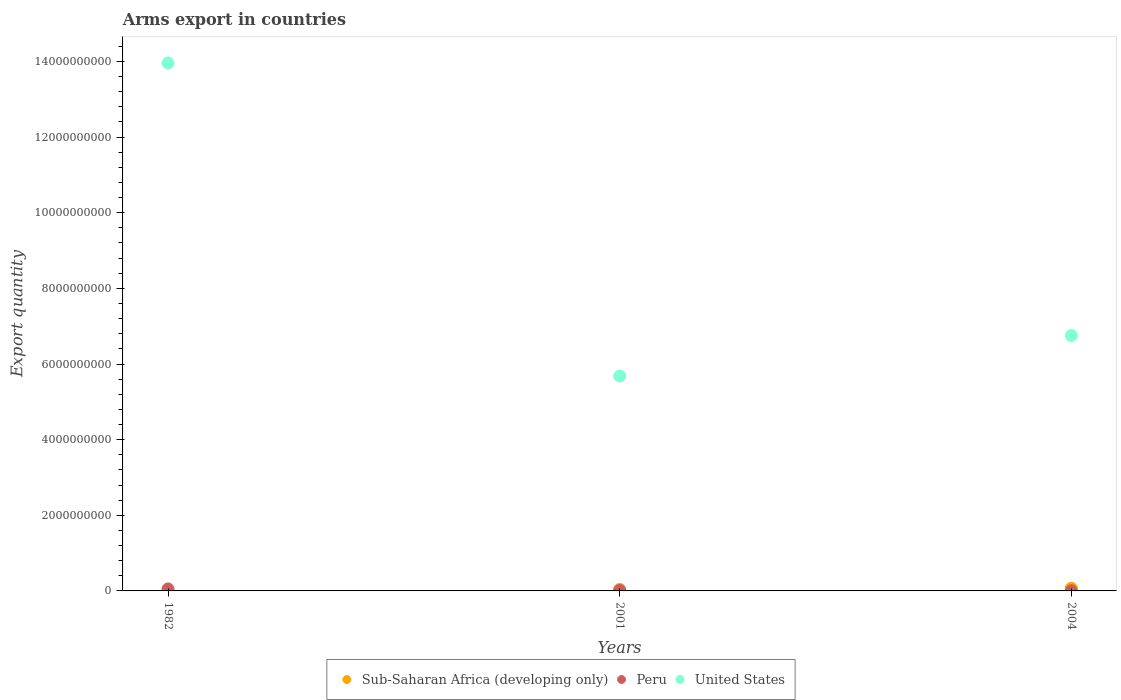How many different coloured dotlines are there?
Offer a terse response. 3. What is the total arms export in United States in 2004?
Provide a short and direct response. 6.75e+09. Across all years, what is the maximum total arms export in Peru?
Offer a terse response. 5.30e+07. Across all years, what is the minimum total arms export in United States?
Keep it short and to the point. 5.68e+09. In which year was the total arms export in United States minimum?
Ensure brevity in your answer.  2001. What is the total total arms export in Sub-Saharan Africa (developing only) in the graph?
Make the answer very short. 1.14e+08. What is the difference between the total arms export in Peru in 1982 and that in 2004?
Your answer should be very brief. 4.80e+07. What is the difference between the total arms export in United States in 2004 and the total arms export in Sub-Saharan Africa (developing only) in 1982?
Your response must be concise. 6.75e+09. What is the average total arms export in Sub-Saharan Africa (developing only) per year?
Provide a short and direct response. 3.80e+07. In the year 1982, what is the difference between the total arms export in United States and total arms export in Sub-Saharan Africa (developing only)?
Offer a very short reply. 1.40e+1. In how many years, is the total arms export in Sub-Saharan Africa (developing only) greater than 4000000000?
Your answer should be very brief. 0. What is the ratio of the total arms export in United States in 1982 to that in 2001?
Your response must be concise. 2.46. Is the total arms export in Sub-Saharan Africa (developing only) in 1982 less than that in 2004?
Give a very brief answer. Yes. What is the difference between the highest and the second highest total arms export in Peru?
Make the answer very short. 3.90e+07. What is the difference between the highest and the lowest total arms export in United States?
Ensure brevity in your answer.  8.28e+09. Is the sum of the total arms export in Sub-Saharan Africa (developing only) in 1982 and 2004 greater than the maximum total arms export in United States across all years?
Provide a succinct answer. No. How many dotlines are there?
Make the answer very short. 3. How many years are there in the graph?
Your response must be concise. 3. What is the difference between two consecutive major ticks on the Y-axis?
Ensure brevity in your answer.  2.00e+09. Are the values on the major ticks of Y-axis written in scientific E-notation?
Your answer should be compact. No. How are the legend labels stacked?
Provide a short and direct response. Horizontal. What is the title of the graph?
Ensure brevity in your answer.  Arms export in countries. What is the label or title of the X-axis?
Keep it short and to the point. Years. What is the label or title of the Y-axis?
Your response must be concise. Export quantity. What is the Export quantity of Peru in 1982?
Your answer should be very brief. 5.30e+07. What is the Export quantity in United States in 1982?
Your answer should be compact. 1.40e+1. What is the Export quantity in Sub-Saharan Africa (developing only) in 2001?
Offer a terse response. 4.10e+07. What is the Export quantity of Peru in 2001?
Provide a succinct answer. 1.40e+07. What is the Export quantity in United States in 2001?
Make the answer very short. 5.68e+09. What is the Export quantity of Sub-Saharan Africa (developing only) in 2004?
Your answer should be compact. 7.20e+07. What is the Export quantity of United States in 2004?
Your response must be concise. 6.75e+09. Across all years, what is the maximum Export quantity in Sub-Saharan Africa (developing only)?
Your answer should be very brief. 7.20e+07. Across all years, what is the maximum Export quantity in Peru?
Provide a short and direct response. 5.30e+07. Across all years, what is the maximum Export quantity of United States?
Your response must be concise. 1.40e+1. Across all years, what is the minimum Export quantity of United States?
Provide a short and direct response. 5.68e+09. What is the total Export quantity of Sub-Saharan Africa (developing only) in the graph?
Offer a terse response. 1.14e+08. What is the total Export quantity in Peru in the graph?
Your answer should be very brief. 7.20e+07. What is the total Export quantity in United States in the graph?
Offer a terse response. 2.64e+1. What is the difference between the Export quantity in Sub-Saharan Africa (developing only) in 1982 and that in 2001?
Ensure brevity in your answer.  -4.00e+07. What is the difference between the Export quantity in Peru in 1982 and that in 2001?
Offer a very short reply. 3.90e+07. What is the difference between the Export quantity of United States in 1982 and that in 2001?
Keep it short and to the point. 8.28e+09. What is the difference between the Export quantity of Sub-Saharan Africa (developing only) in 1982 and that in 2004?
Your answer should be very brief. -7.10e+07. What is the difference between the Export quantity of Peru in 1982 and that in 2004?
Give a very brief answer. 4.80e+07. What is the difference between the Export quantity of United States in 1982 and that in 2004?
Keep it short and to the point. 7.21e+09. What is the difference between the Export quantity of Sub-Saharan Africa (developing only) in 2001 and that in 2004?
Your answer should be compact. -3.10e+07. What is the difference between the Export quantity of Peru in 2001 and that in 2004?
Provide a short and direct response. 9.00e+06. What is the difference between the Export quantity of United States in 2001 and that in 2004?
Offer a terse response. -1.07e+09. What is the difference between the Export quantity of Sub-Saharan Africa (developing only) in 1982 and the Export quantity of Peru in 2001?
Your answer should be very brief. -1.30e+07. What is the difference between the Export quantity in Sub-Saharan Africa (developing only) in 1982 and the Export quantity in United States in 2001?
Your answer should be very brief. -5.68e+09. What is the difference between the Export quantity in Peru in 1982 and the Export quantity in United States in 2001?
Your response must be concise. -5.63e+09. What is the difference between the Export quantity of Sub-Saharan Africa (developing only) in 1982 and the Export quantity of Peru in 2004?
Offer a very short reply. -4.00e+06. What is the difference between the Export quantity in Sub-Saharan Africa (developing only) in 1982 and the Export quantity in United States in 2004?
Ensure brevity in your answer.  -6.75e+09. What is the difference between the Export quantity of Peru in 1982 and the Export quantity of United States in 2004?
Offer a very short reply. -6.70e+09. What is the difference between the Export quantity of Sub-Saharan Africa (developing only) in 2001 and the Export quantity of Peru in 2004?
Your answer should be compact. 3.60e+07. What is the difference between the Export quantity of Sub-Saharan Africa (developing only) in 2001 and the Export quantity of United States in 2004?
Give a very brief answer. -6.71e+09. What is the difference between the Export quantity in Peru in 2001 and the Export quantity in United States in 2004?
Provide a succinct answer. -6.74e+09. What is the average Export quantity of Sub-Saharan Africa (developing only) per year?
Provide a succinct answer. 3.80e+07. What is the average Export quantity in Peru per year?
Provide a short and direct response. 2.40e+07. What is the average Export quantity in United States per year?
Your response must be concise. 8.80e+09. In the year 1982, what is the difference between the Export quantity in Sub-Saharan Africa (developing only) and Export quantity in Peru?
Offer a very short reply. -5.20e+07. In the year 1982, what is the difference between the Export quantity of Sub-Saharan Africa (developing only) and Export quantity of United States?
Offer a very short reply. -1.40e+1. In the year 1982, what is the difference between the Export quantity in Peru and Export quantity in United States?
Offer a terse response. -1.39e+1. In the year 2001, what is the difference between the Export quantity in Sub-Saharan Africa (developing only) and Export quantity in Peru?
Keep it short and to the point. 2.70e+07. In the year 2001, what is the difference between the Export quantity in Sub-Saharan Africa (developing only) and Export quantity in United States?
Give a very brief answer. -5.64e+09. In the year 2001, what is the difference between the Export quantity in Peru and Export quantity in United States?
Keep it short and to the point. -5.67e+09. In the year 2004, what is the difference between the Export quantity of Sub-Saharan Africa (developing only) and Export quantity of Peru?
Provide a succinct answer. 6.70e+07. In the year 2004, what is the difference between the Export quantity of Sub-Saharan Africa (developing only) and Export quantity of United States?
Ensure brevity in your answer.  -6.68e+09. In the year 2004, what is the difference between the Export quantity of Peru and Export quantity of United States?
Your answer should be compact. -6.75e+09. What is the ratio of the Export quantity in Sub-Saharan Africa (developing only) in 1982 to that in 2001?
Provide a short and direct response. 0.02. What is the ratio of the Export quantity in Peru in 1982 to that in 2001?
Keep it short and to the point. 3.79. What is the ratio of the Export quantity of United States in 1982 to that in 2001?
Make the answer very short. 2.46. What is the ratio of the Export quantity in Sub-Saharan Africa (developing only) in 1982 to that in 2004?
Ensure brevity in your answer.  0.01. What is the ratio of the Export quantity in Peru in 1982 to that in 2004?
Ensure brevity in your answer.  10.6. What is the ratio of the Export quantity in United States in 1982 to that in 2004?
Ensure brevity in your answer.  2.07. What is the ratio of the Export quantity in Sub-Saharan Africa (developing only) in 2001 to that in 2004?
Ensure brevity in your answer.  0.57. What is the ratio of the Export quantity in United States in 2001 to that in 2004?
Make the answer very short. 0.84. What is the difference between the highest and the second highest Export quantity in Sub-Saharan Africa (developing only)?
Make the answer very short. 3.10e+07. What is the difference between the highest and the second highest Export quantity of Peru?
Offer a very short reply. 3.90e+07. What is the difference between the highest and the second highest Export quantity in United States?
Keep it short and to the point. 7.21e+09. What is the difference between the highest and the lowest Export quantity of Sub-Saharan Africa (developing only)?
Your response must be concise. 7.10e+07. What is the difference between the highest and the lowest Export quantity of Peru?
Your answer should be compact. 4.80e+07. What is the difference between the highest and the lowest Export quantity in United States?
Provide a short and direct response. 8.28e+09. 